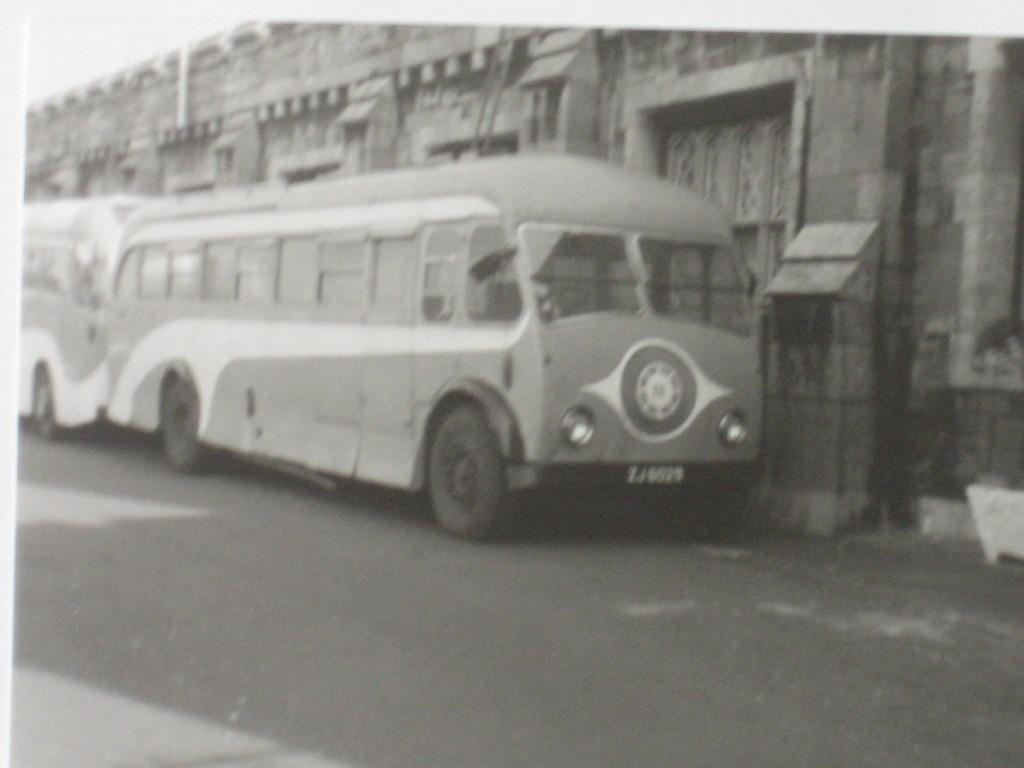How many vehicles can be seen on the road in the image? There are two vehicles on the road in the image. What can be seen in the background of the image? There is a building and the sky visible in the background of the image. What is the color scheme of the image? The image is in black and white. What type of locket is hanging from the lamp in the image? There is no locket or lamp present in the image; it is a black and white image of vehicles on a road with a building and sky in the background. 